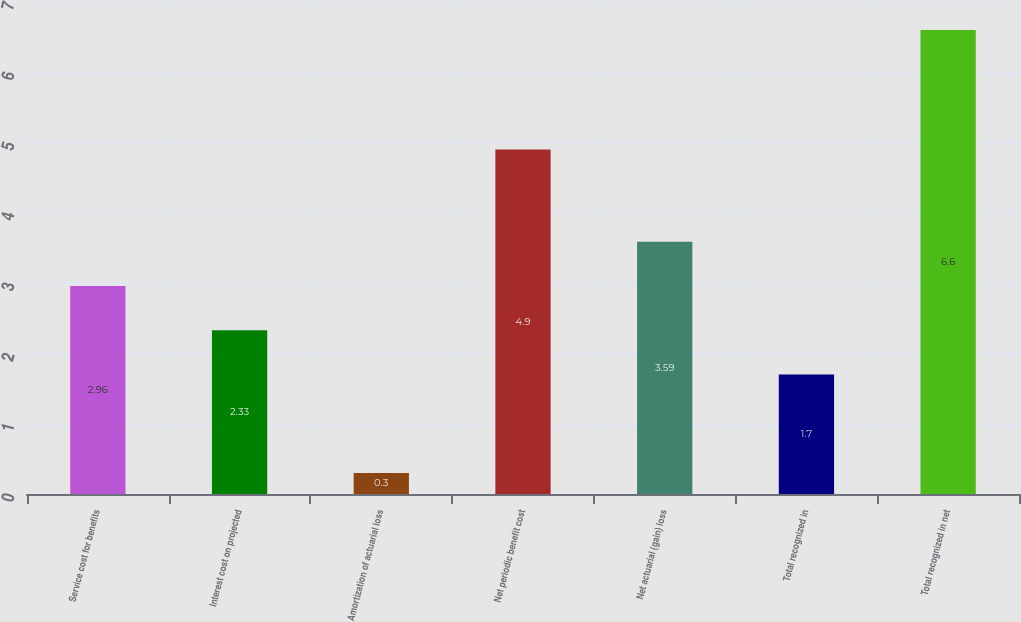Convert chart. <chart><loc_0><loc_0><loc_500><loc_500><bar_chart><fcel>Service cost for benefits<fcel>Interest cost on projected<fcel>Amortization of actuarial loss<fcel>Net periodic benefit cost<fcel>Net actuarial (gain) loss<fcel>Total recognized in<fcel>Total recognized in net<nl><fcel>2.96<fcel>2.33<fcel>0.3<fcel>4.9<fcel>3.59<fcel>1.7<fcel>6.6<nl></chart> 